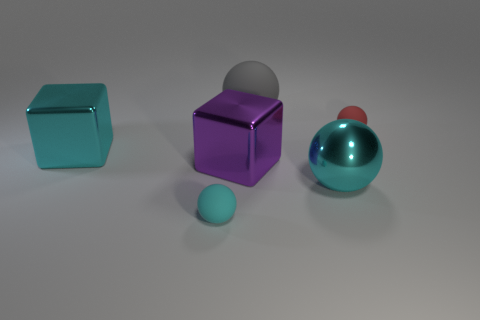What is the size of the cube that is the same color as the metal sphere?
Your answer should be compact. Large. What color is the shiny object that is the same shape as the red rubber object?
Your response must be concise. Cyan. How many tiny objects are the same color as the large shiny ball?
Your response must be concise. 1. There is a big rubber object; is it the same color as the big shiny cube behind the large purple metallic object?
Offer a terse response. No. There is a object that is behind the purple shiny block and to the right of the gray ball; what is its shape?
Give a very brief answer. Sphere. The big gray sphere that is on the right side of the tiny ball in front of the small matte sphere on the right side of the cyan rubber sphere is made of what material?
Keep it short and to the point. Rubber. Are there more large cyan shiny blocks behind the tiny cyan ball than cyan rubber things behind the gray ball?
Make the answer very short. Yes. How many big spheres are the same material as the red thing?
Give a very brief answer. 1. Do the cyan metal object behind the large purple shiny block and the gray thing behind the big purple thing have the same shape?
Your answer should be compact. No. What is the color of the matte object in front of the large cyan metallic block?
Give a very brief answer. Cyan. 